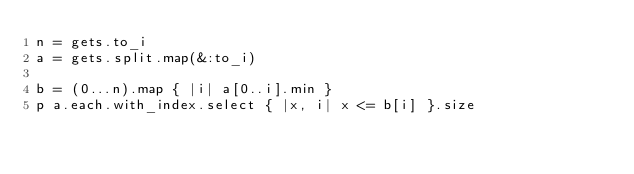<code> <loc_0><loc_0><loc_500><loc_500><_Ruby_>n = gets.to_i
a = gets.split.map(&:to_i)

b = (0...n).map { |i| a[0..i].min }
p a.each.with_index.select { |x, i| x <= b[i] }.size</code> 